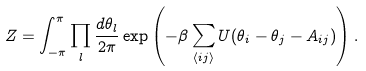Convert formula to latex. <formula><loc_0><loc_0><loc_500><loc_500>Z = \int _ { - \pi } ^ { \pi } \prod _ { l } \frac { d \theta _ { l } } { 2 \pi } \exp \left ( - \beta \sum _ { \left < i j \right > } U ( \theta _ { i } - \theta _ { j } - A _ { i j } ) \right ) .</formula> 